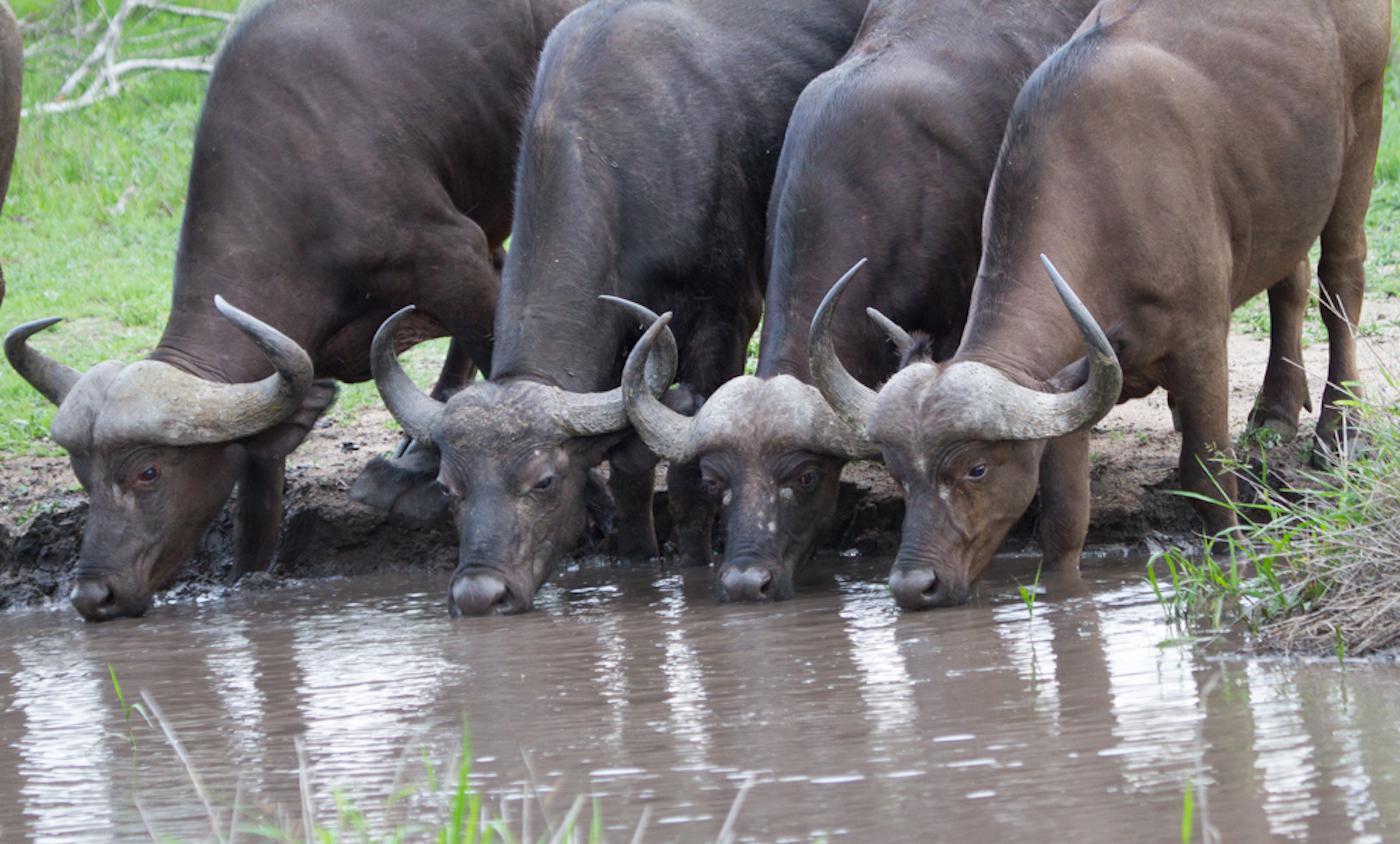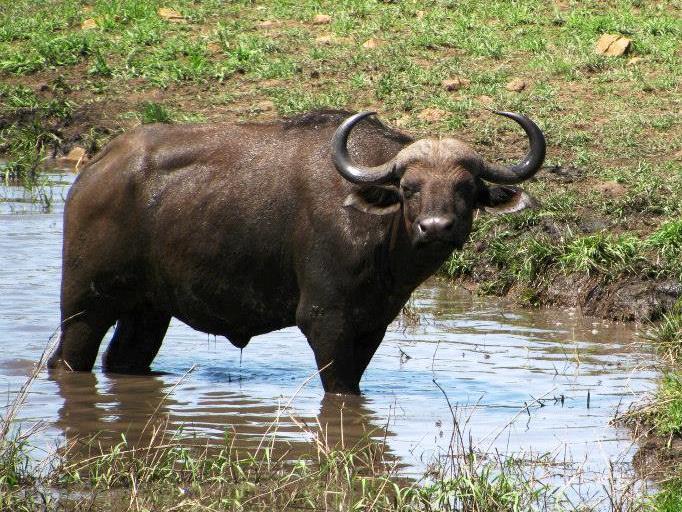The first image is the image on the left, the second image is the image on the right. For the images shown, is this caption "The buffalo in the right image has its head down in the grass." true? Answer yes or no. No. The first image is the image on the left, the second image is the image on the right. Given the left and right images, does the statement "An image shows exactly one water buffalo standing in wet area." hold true? Answer yes or no. Yes. 